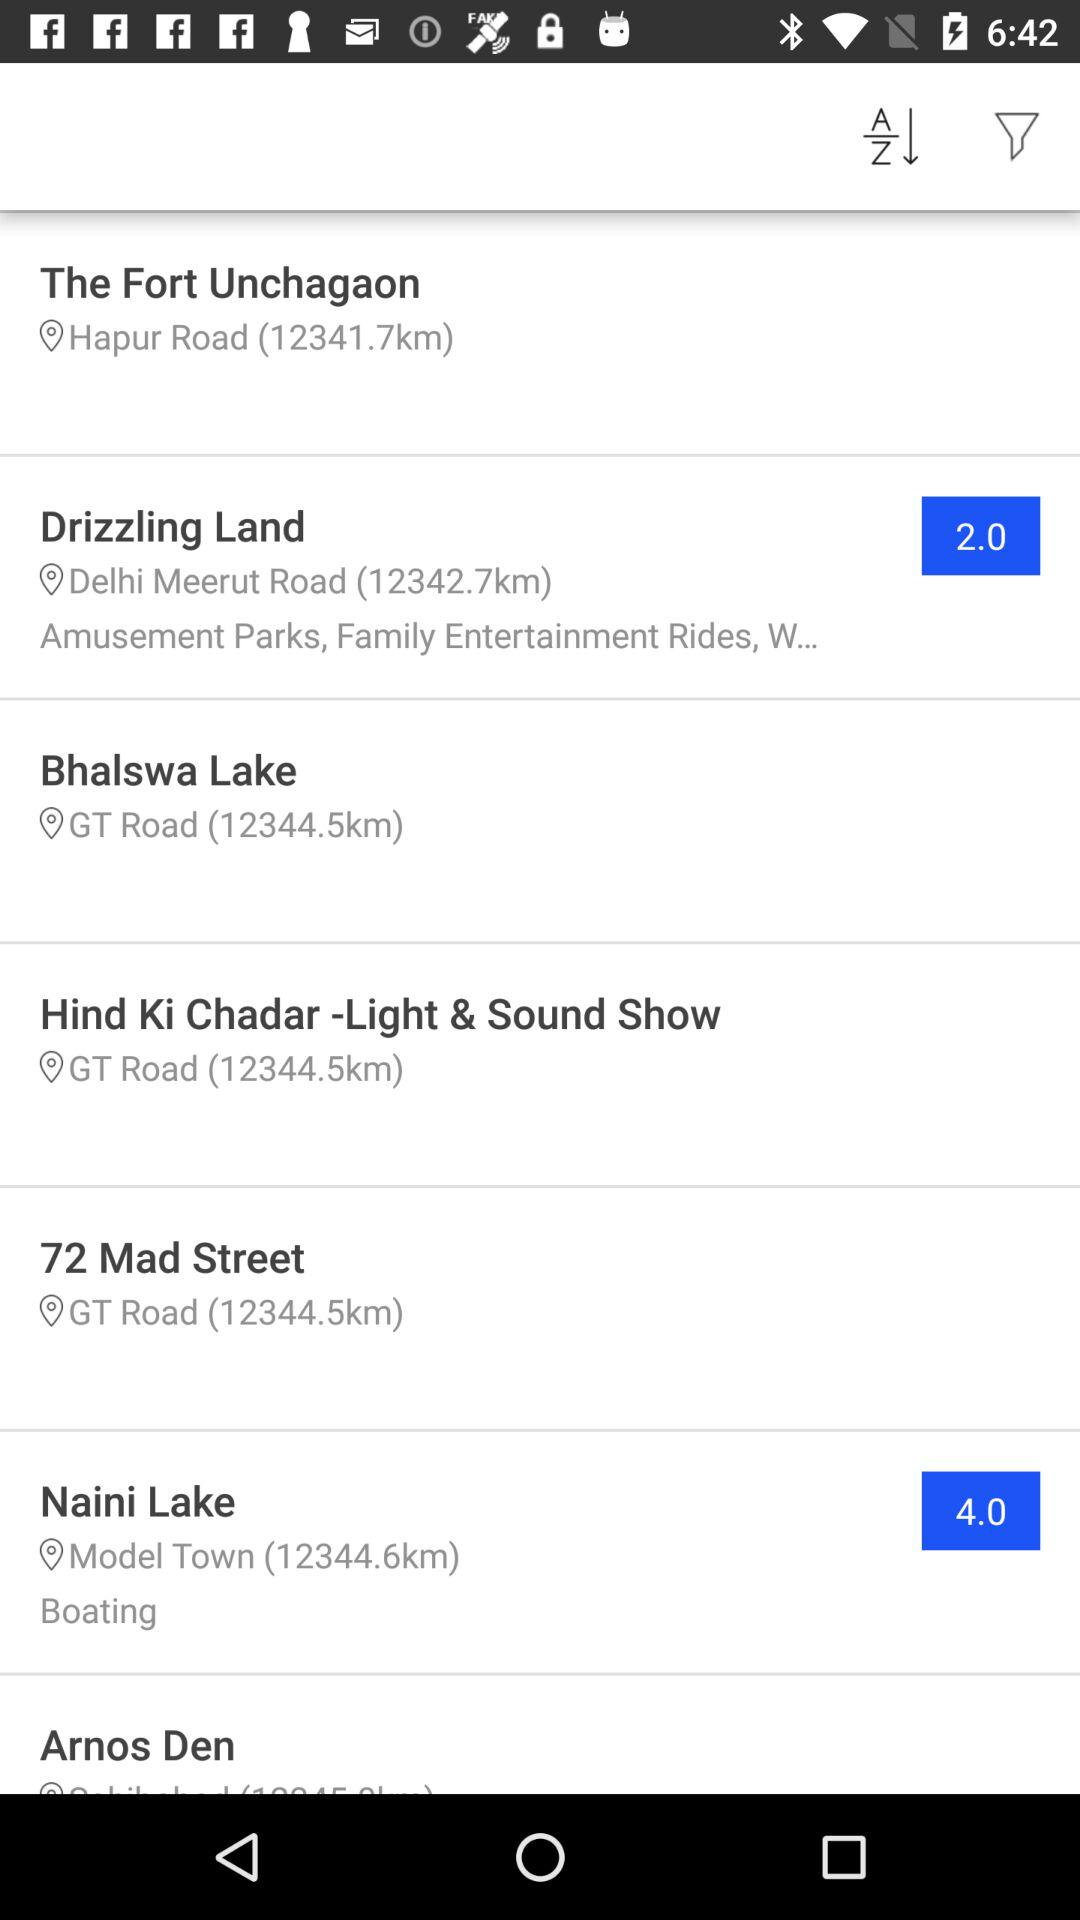How far is Bhalswa Lake from you? The Bhalswa Lake is 12344.5km. 